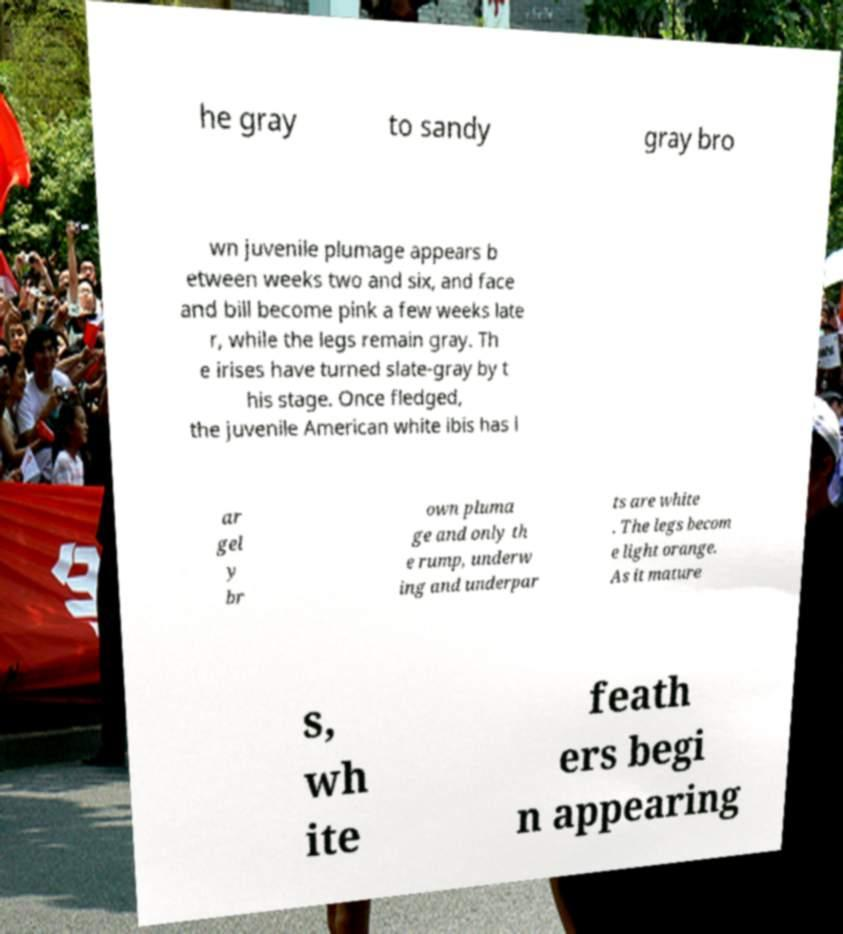Can you accurately transcribe the text from the provided image for me? he gray to sandy gray bro wn juvenile plumage appears b etween weeks two and six, and face and bill become pink a few weeks late r, while the legs remain gray. Th e irises have turned slate-gray by t his stage. Once fledged, the juvenile American white ibis has l ar gel y br own pluma ge and only th e rump, underw ing and underpar ts are white . The legs becom e light orange. As it mature s, wh ite feath ers begi n appearing 